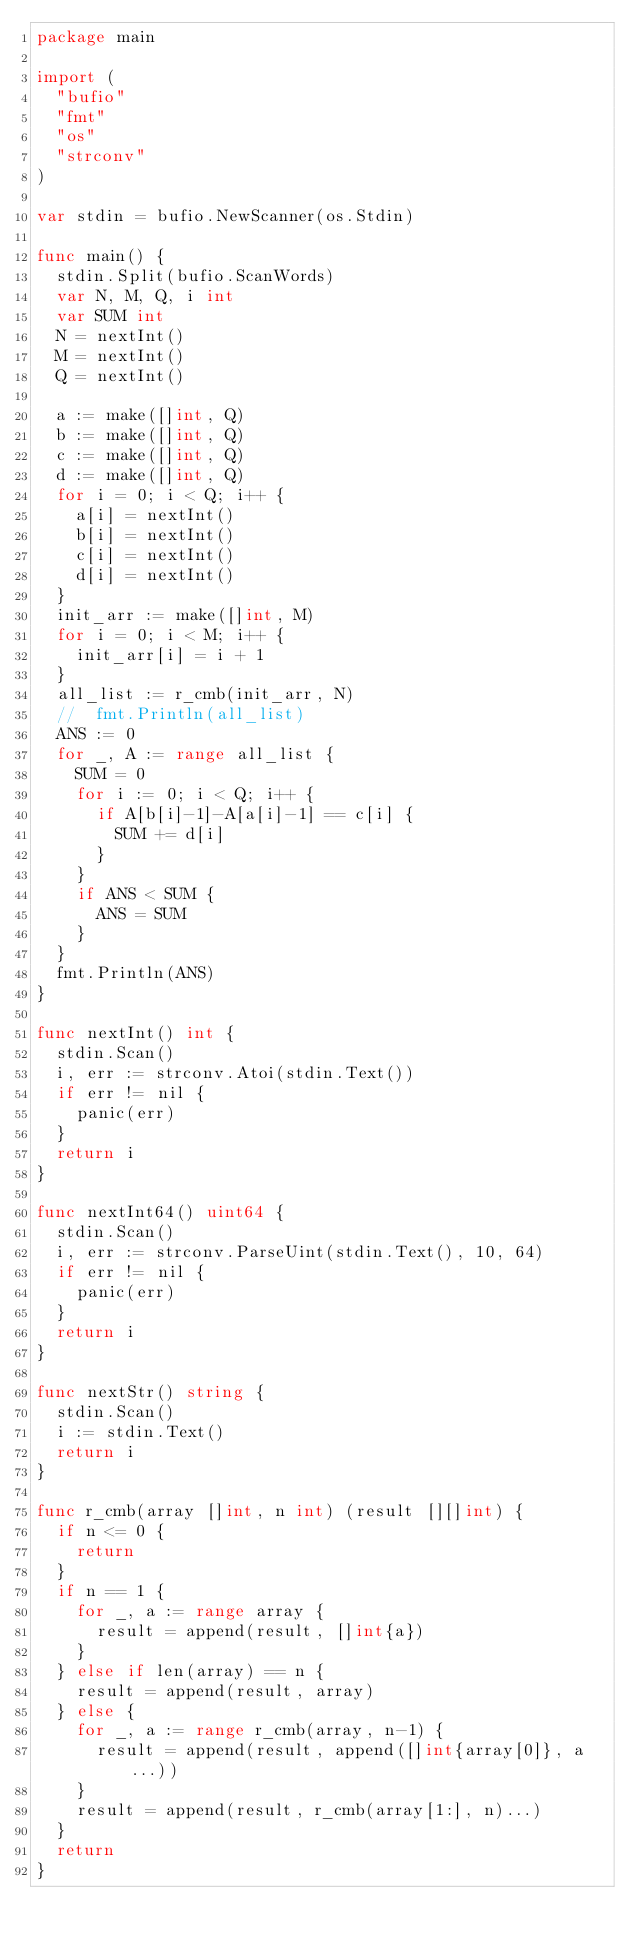<code> <loc_0><loc_0><loc_500><loc_500><_Go_>package main

import (
	"bufio"
	"fmt"
	"os"
	"strconv"
)

var stdin = bufio.NewScanner(os.Stdin)

func main() {
	stdin.Split(bufio.ScanWords)
	var N, M, Q, i int
	var SUM int
	N = nextInt()
	M = nextInt()
	Q = nextInt()

	a := make([]int, Q)
	b := make([]int, Q)
	c := make([]int, Q)
	d := make([]int, Q)
	for i = 0; i < Q; i++ {
		a[i] = nextInt()
		b[i] = nextInt()
		c[i] = nextInt()
		d[i] = nextInt()
	}
	init_arr := make([]int, M)
	for i = 0; i < M; i++ {
		init_arr[i] = i + 1
	}
	all_list := r_cmb(init_arr, N)
	//	fmt.Println(all_list)
	ANS := 0
	for _, A := range all_list {
		SUM = 0
		for i := 0; i < Q; i++ {
			if A[b[i]-1]-A[a[i]-1] == c[i] {
				SUM += d[i]
			}
		}
		if ANS < SUM {
			ANS = SUM
		}
	}
	fmt.Println(ANS)
}

func nextInt() int {
	stdin.Scan()
	i, err := strconv.Atoi(stdin.Text())
	if err != nil {
		panic(err)
	}
	return i
}

func nextInt64() uint64 {
	stdin.Scan()
	i, err := strconv.ParseUint(stdin.Text(), 10, 64)
	if err != nil {
		panic(err)
	}
	return i
}

func nextStr() string {
	stdin.Scan()
	i := stdin.Text()
	return i
}

func r_cmb(array []int, n int) (result [][]int) {
	if n <= 0 {
		return
	}
	if n == 1 {
		for _, a := range array {
			result = append(result, []int{a})
		}
	} else if len(array) == n {
		result = append(result, array)
	} else {
		for _, a := range r_cmb(array, n-1) {
			result = append(result, append([]int{array[0]}, a...))
		}
		result = append(result, r_cmb(array[1:], n)...)
	}
	return
}
</code> 